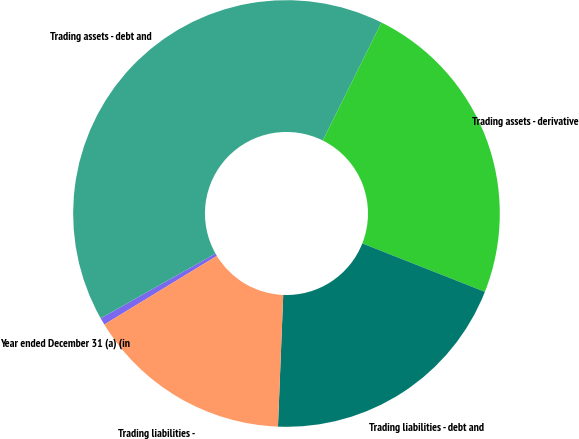Convert chart to OTSL. <chart><loc_0><loc_0><loc_500><loc_500><pie_chart><fcel>Year ended December 31 (a) (in<fcel>Trading assets - debt and<fcel>Trading assets - derivative<fcel>Trading liabilities - debt and<fcel>Trading liabilities -<nl><fcel>0.54%<fcel>40.52%<fcel>23.64%<fcel>19.65%<fcel>15.65%<nl></chart> 